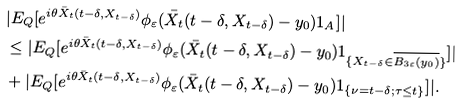<formula> <loc_0><loc_0><loc_500><loc_500>& | E _ { Q } [ e ^ { i \theta \bar { X } _ { t } ( t - \delta , X _ { t - \delta } ) } \phi _ { \varepsilon } ( \bar { X } _ { t } ( t - \delta , X _ { t - \delta } ) - y _ { 0 } ) 1 _ { A } ] | \\ & \leq | E _ { Q } [ e ^ { i \theta \bar { X } _ { t } ( t - \delta , X _ { t - \delta } ) } \phi _ { \varepsilon } ( \bar { X } _ { t } ( t - \delta , X _ { t - \delta } ) - y _ { 0 } ) 1 _ { \{ X _ { t - \delta } \in \overline { B _ { 3 \varepsilon } ( y _ { 0 } ) } \} } ] | \\ & + | E _ { Q } [ e ^ { i \theta \bar { X } _ { t } ( t - \delta , X _ { t - \delta } ) } \phi _ { \varepsilon } ( \bar { X } _ { t } ( t - \delta , X _ { t - \delta } ) - y _ { 0 } ) 1 _ { \{ \nu = t - \delta ; \tau \leq t \} } ] | .</formula> 